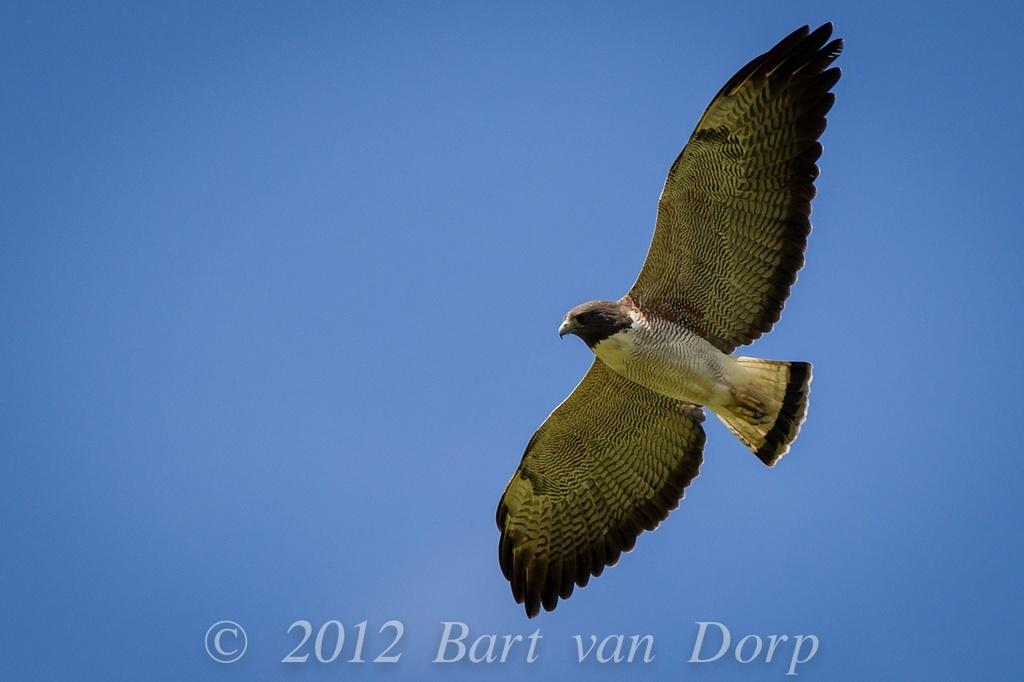What is the main subject of the image? There is a bird flying in the image. What can be seen in the background of the image? The sky is visible at the top of the image. What is present at the bottom of the image? There is text at the bottom of the image. What direction is the church facing in the image? There is no church present in the image. What type of cream is being used by the bird in the image? There is no cream present in the image, and the bird is not using any cream. 